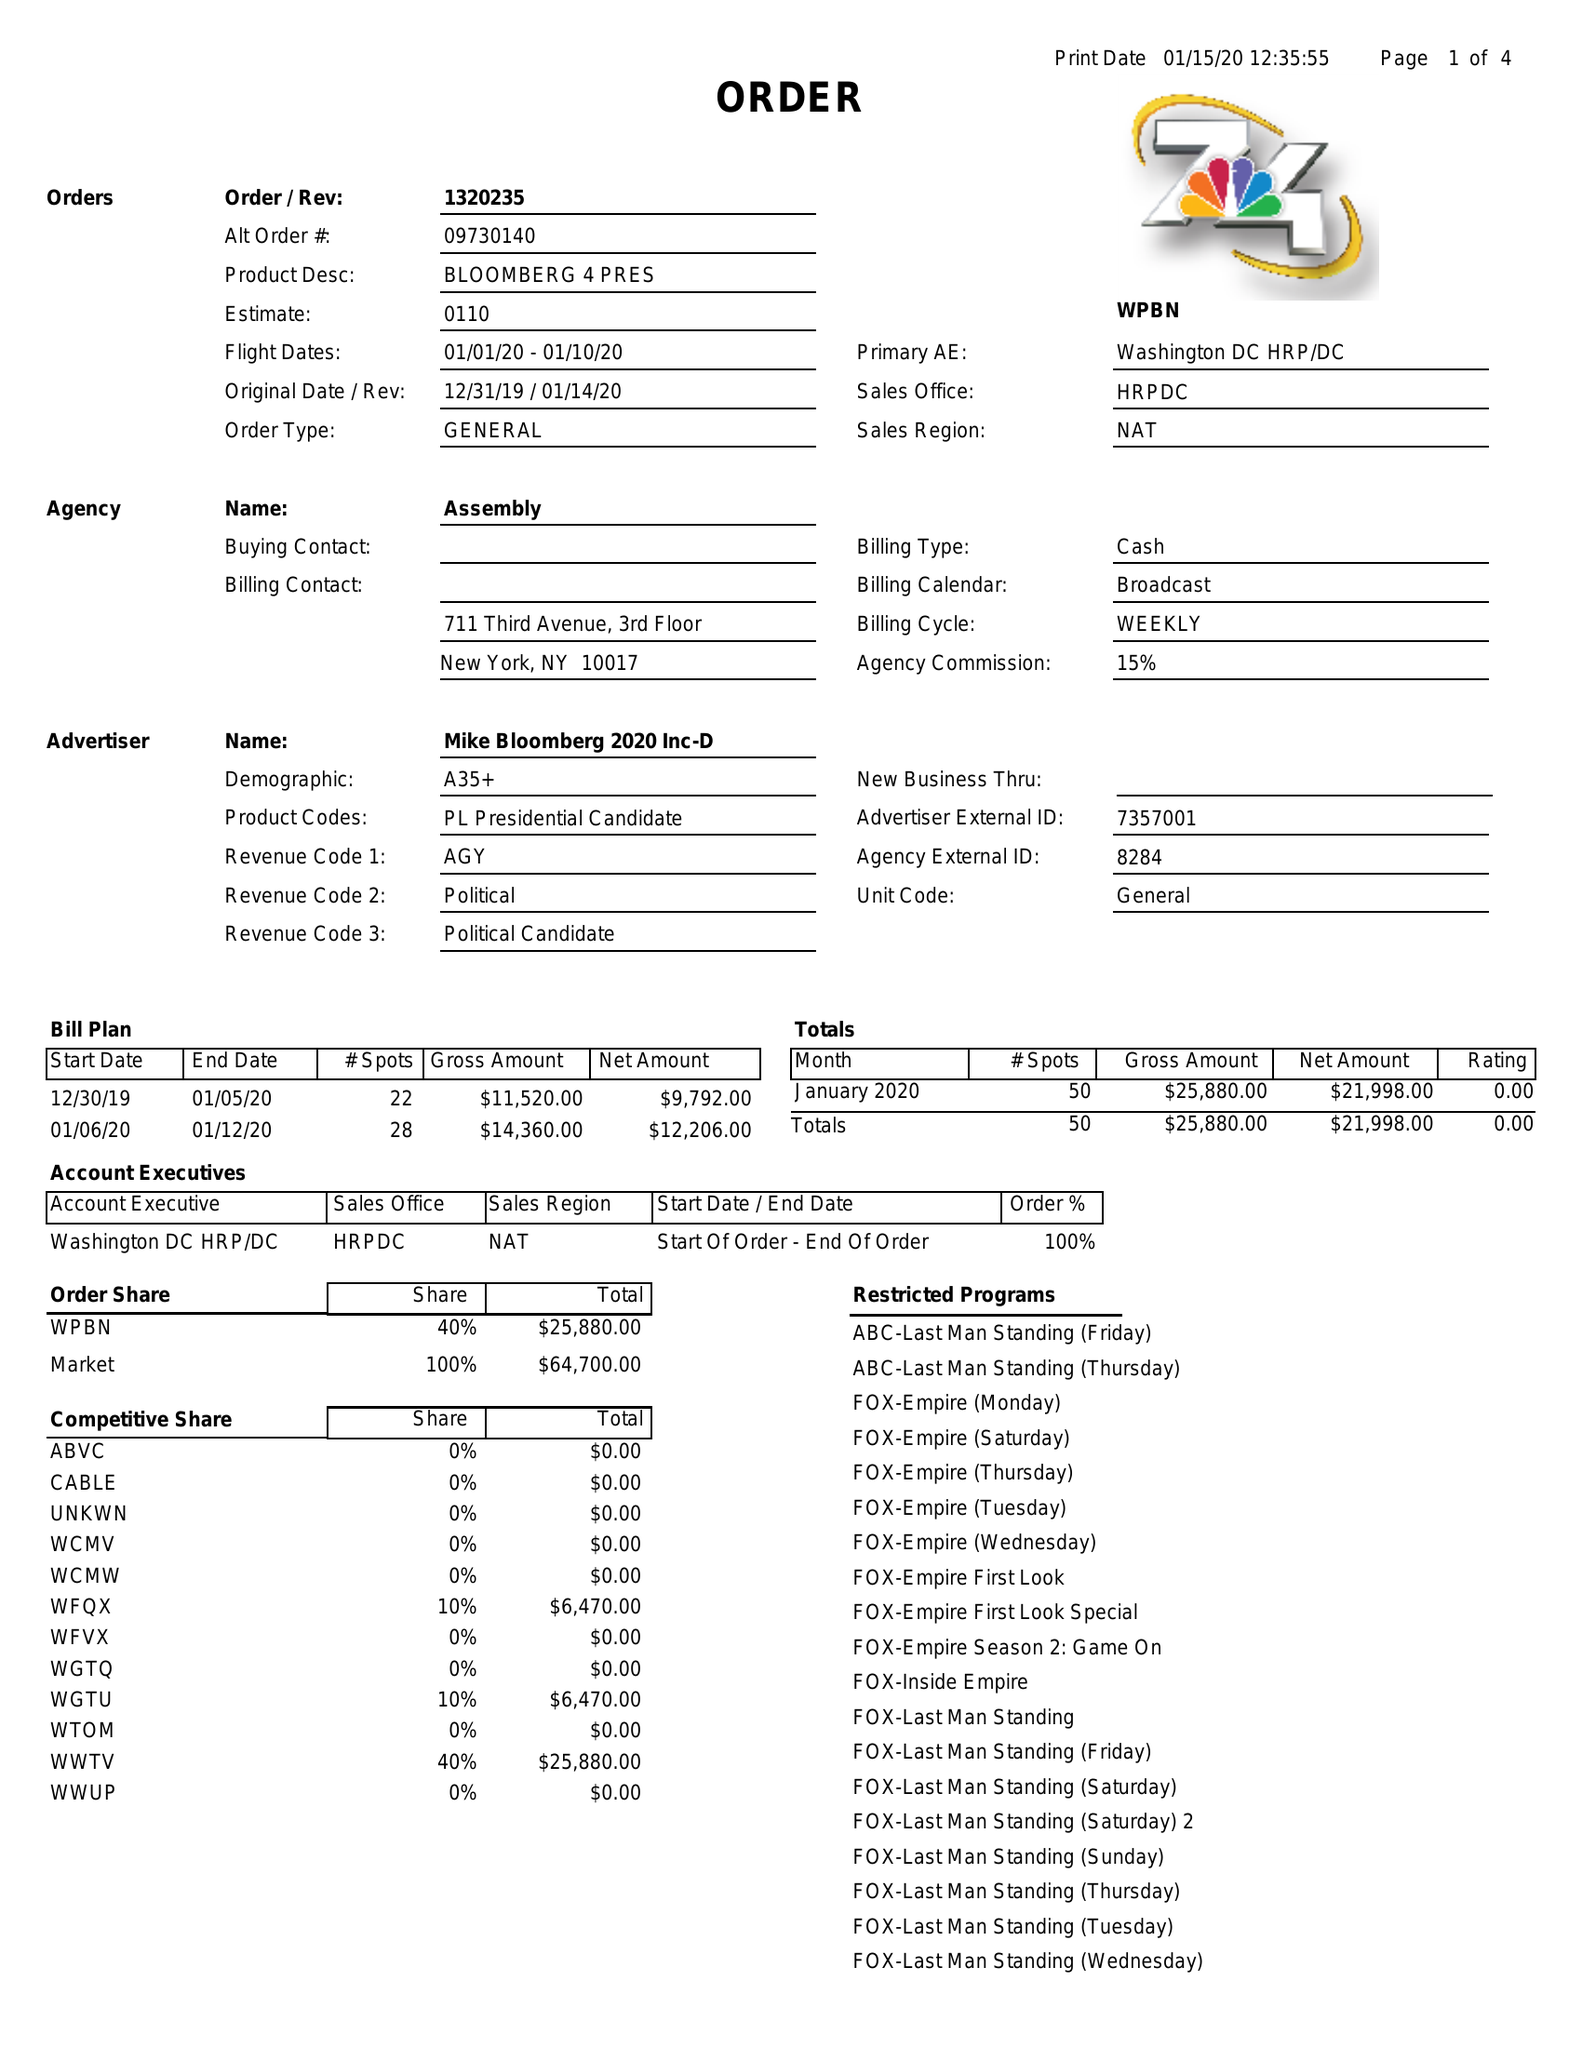What is the value for the flight_to?
Answer the question using a single word or phrase. 01/10/20 